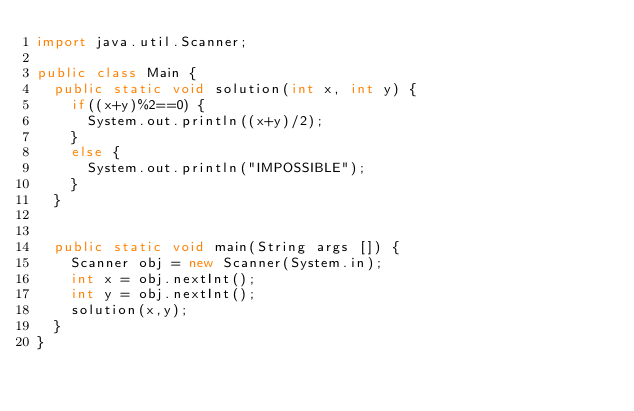<code> <loc_0><loc_0><loc_500><loc_500><_Java_>import java.util.Scanner;

public class Main {
	public static void solution(int x, int y) {
		if((x+y)%2==0) {
			System.out.println((x+y)/2);
		}
		else {
			System.out.println("IMPOSSIBLE");
		}
	}
		
	
	public static void main(String args []) {
		Scanner obj = new Scanner(System.in);
		int x = obj.nextInt();
		int y = obj.nextInt();
		solution(x,y);
	}
}</code> 